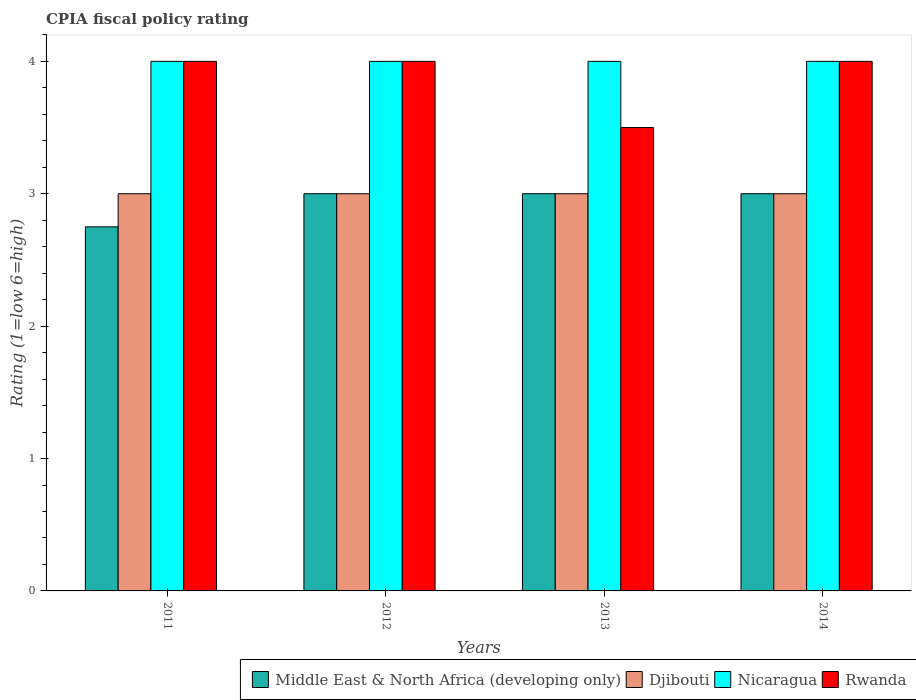How many groups of bars are there?
Provide a succinct answer. 4. Are the number of bars per tick equal to the number of legend labels?
Provide a succinct answer. Yes. Are the number of bars on each tick of the X-axis equal?
Your response must be concise. Yes. How many bars are there on the 1st tick from the right?
Keep it short and to the point. 4. What is the label of the 1st group of bars from the left?
Provide a short and direct response. 2011. What is the CPIA rating in Nicaragua in 2011?
Provide a short and direct response. 4. Across all years, what is the maximum CPIA rating in Nicaragua?
Your answer should be compact. 4. Across all years, what is the minimum CPIA rating in Rwanda?
Make the answer very short. 3.5. In which year was the CPIA rating in Nicaragua maximum?
Make the answer very short. 2011. What is the total CPIA rating in Djibouti in the graph?
Ensure brevity in your answer.  12. In the year 2011, what is the difference between the CPIA rating in Middle East & North Africa (developing only) and CPIA rating in Rwanda?
Your answer should be compact. -1.25. What is the ratio of the CPIA rating in Nicaragua in 2012 to that in 2013?
Make the answer very short. 1. Is the CPIA rating in Rwanda in 2012 less than that in 2014?
Offer a terse response. No. What is the difference between the highest and the second highest CPIA rating in Middle East & North Africa (developing only)?
Make the answer very short. 0. Is the sum of the CPIA rating in Middle East & North Africa (developing only) in 2012 and 2014 greater than the maximum CPIA rating in Rwanda across all years?
Provide a short and direct response. Yes. Is it the case that in every year, the sum of the CPIA rating in Nicaragua and CPIA rating in Djibouti is greater than the sum of CPIA rating in Rwanda and CPIA rating in Middle East & North Africa (developing only)?
Offer a terse response. No. What does the 3rd bar from the left in 2011 represents?
Your answer should be compact. Nicaragua. What does the 2nd bar from the right in 2013 represents?
Ensure brevity in your answer.  Nicaragua. How many bars are there?
Offer a terse response. 16. Are all the bars in the graph horizontal?
Your answer should be compact. No. Where does the legend appear in the graph?
Your response must be concise. Bottom right. How are the legend labels stacked?
Your answer should be very brief. Horizontal. What is the title of the graph?
Your answer should be very brief. CPIA fiscal policy rating. Does "Euro area" appear as one of the legend labels in the graph?
Your answer should be compact. No. What is the label or title of the X-axis?
Provide a short and direct response. Years. What is the Rating (1=low 6=high) in Middle East & North Africa (developing only) in 2011?
Give a very brief answer. 2.75. What is the Rating (1=low 6=high) in Middle East & North Africa (developing only) in 2012?
Offer a very short reply. 3. What is the Rating (1=low 6=high) in Djibouti in 2012?
Keep it short and to the point. 3. What is the Rating (1=low 6=high) in Djibouti in 2013?
Your answer should be very brief. 3. What is the Rating (1=low 6=high) in Nicaragua in 2013?
Your answer should be very brief. 4. What is the Rating (1=low 6=high) of Djibouti in 2014?
Your answer should be very brief. 3. What is the Rating (1=low 6=high) of Rwanda in 2014?
Give a very brief answer. 4. Across all years, what is the maximum Rating (1=low 6=high) in Djibouti?
Your answer should be compact. 3. Across all years, what is the maximum Rating (1=low 6=high) in Rwanda?
Make the answer very short. 4. Across all years, what is the minimum Rating (1=low 6=high) in Middle East & North Africa (developing only)?
Provide a succinct answer. 2.75. Across all years, what is the minimum Rating (1=low 6=high) of Nicaragua?
Provide a succinct answer. 4. Across all years, what is the minimum Rating (1=low 6=high) of Rwanda?
Your response must be concise. 3.5. What is the total Rating (1=low 6=high) of Middle East & North Africa (developing only) in the graph?
Make the answer very short. 11.75. What is the difference between the Rating (1=low 6=high) in Nicaragua in 2011 and that in 2012?
Your response must be concise. 0. What is the difference between the Rating (1=low 6=high) in Rwanda in 2011 and that in 2012?
Offer a terse response. 0. What is the difference between the Rating (1=low 6=high) in Djibouti in 2011 and that in 2013?
Make the answer very short. 0. What is the difference between the Rating (1=low 6=high) in Middle East & North Africa (developing only) in 2011 and that in 2014?
Offer a terse response. -0.25. What is the difference between the Rating (1=low 6=high) of Djibouti in 2011 and that in 2014?
Make the answer very short. 0. What is the difference between the Rating (1=low 6=high) of Nicaragua in 2011 and that in 2014?
Make the answer very short. 0. What is the difference between the Rating (1=low 6=high) of Rwanda in 2011 and that in 2014?
Offer a terse response. 0. What is the difference between the Rating (1=low 6=high) of Middle East & North Africa (developing only) in 2012 and that in 2013?
Your response must be concise. 0. What is the difference between the Rating (1=low 6=high) of Djibouti in 2012 and that in 2013?
Your response must be concise. 0. What is the difference between the Rating (1=low 6=high) of Nicaragua in 2012 and that in 2013?
Give a very brief answer. 0. What is the difference between the Rating (1=low 6=high) of Middle East & North Africa (developing only) in 2012 and that in 2014?
Offer a very short reply. 0. What is the difference between the Rating (1=low 6=high) of Rwanda in 2012 and that in 2014?
Keep it short and to the point. 0. What is the difference between the Rating (1=low 6=high) in Middle East & North Africa (developing only) in 2013 and that in 2014?
Your answer should be compact. 0. What is the difference between the Rating (1=low 6=high) of Middle East & North Africa (developing only) in 2011 and the Rating (1=low 6=high) of Nicaragua in 2012?
Ensure brevity in your answer.  -1.25. What is the difference between the Rating (1=low 6=high) in Middle East & North Africa (developing only) in 2011 and the Rating (1=low 6=high) in Rwanda in 2012?
Provide a succinct answer. -1.25. What is the difference between the Rating (1=low 6=high) of Djibouti in 2011 and the Rating (1=low 6=high) of Rwanda in 2012?
Make the answer very short. -1. What is the difference between the Rating (1=low 6=high) of Nicaragua in 2011 and the Rating (1=low 6=high) of Rwanda in 2012?
Provide a short and direct response. 0. What is the difference between the Rating (1=low 6=high) of Middle East & North Africa (developing only) in 2011 and the Rating (1=low 6=high) of Djibouti in 2013?
Give a very brief answer. -0.25. What is the difference between the Rating (1=low 6=high) in Middle East & North Africa (developing only) in 2011 and the Rating (1=low 6=high) in Nicaragua in 2013?
Provide a short and direct response. -1.25. What is the difference between the Rating (1=low 6=high) in Middle East & North Africa (developing only) in 2011 and the Rating (1=low 6=high) in Rwanda in 2013?
Ensure brevity in your answer.  -0.75. What is the difference between the Rating (1=low 6=high) in Djibouti in 2011 and the Rating (1=low 6=high) in Nicaragua in 2013?
Ensure brevity in your answer.  -1. What is the difference between the Rating (1=low 6=high) in Djibouti in 2011 and the Rating (1=low 6=high) in Rwanda in 2013?
Provide a short and direct response. -0.5. What is the difference between the Rating (1=low 6=high) of Middle East & North Africa (developing only) in 2011 and the Rating (1=low 6=high) of Nicaragua in 2014?
Provide a short and direct response. -1.25. What is the difference between the Rating (1=low 6=high) of Middle East & North Africa (developing only) in 2011 and the Rating (1=low 6=high) of Rwanda in 2014?
Provide a short and direct response. -1.25. What is the difference between the Rating (1=low 6=high) of Middle East & North Africa (developing only) in 2012 and the Rating (1=low 6=high) of Nicaragua in 2013?
Offer a terse response. -1. What is the difference between the Rating (1=low 6=high) in Djibouti in 2012 and the Rating (1=low 6=high) in Nicaragua in 2013?
Provide a short and direct response. -1. What is the difference between the Rating (1=low 6=high) in Djibouti in 2012 and the Rating (1=low 6=high) in Rwanda in 2013?
Make the answer very short. -0.5. What is the difference between the Rating (1=low 6=high) of Nicaragua in 2012 and the Rating (1=low 6=high) of Rwanda in 2013?
Offer a very short reply. 0.5. What is the difference between the Rating (1=low 6=high) in Middle East & North Africa (developing only) in 2012 and the Rating (1=low 6=high) in Nicaragua in 2014?
Offer a terse response. -1. What is the difference between the Rating (1=low 6=high) of Middle East & North Africa (developing only) in 2012 and the Rating (1=low 6=high) of Rwanda in 2014?
Make the answer very short. -1. What is the difference between the Rating (1=low 6=high) in Middle East & North Africa (developing only) in 2013 and the Rating (1=low 6=high) in Djibouti in 2014?
Ensure brevity in your answer.  0. What is the difference between the Rating (1=low 6=high) of Middle East & North Africa (developing only) in 2013 and the Rating (1=low 6=high) of Rwanda in 2014?
Provide a short and direct response. -1. What is the difference between the Rating (1=low 6=high) in Djibouti in 2013 and the Rating (1=low 6=high) in Nicaragua in 2014?
Offer a very short reply. -1. What is the difference between the Rating (1=low 6=high) in Nicaragua in 2013 and the Rating (1=low 6=high) in Rwanda in 2014?
Give a very brief answer. 0. What is the average Rating (1=low 6=high) of Middle East & North Africa (developing only) per year?
Ensure brevity in your answer.  2.94. What is the average Rating (1=low 6=high) of Rwanda per year?
Your answer should be compact. 3.88. In the year 2011, what is the difference between the Rating (1=low 6=high) of Middle East & North Africa (developing only) and Rating (1=low 6=high) of Djibouti?
Ensure brevity in your answer.  -0.25. In the year 2011, what is the difference between the Rating (1=low 6=high) of Middle East & North Africa (developing only) and Rating (1=low 6=high) of Nicaragua?
Your response must be concise. -1.25. In the year 2011, what is the difference between the Rating (1=low 6=high) of Middle East & North Africa (developing only) and Rating (1=low 6=high) of Rwanda?
Provide a short and direct response. -1.25. In the year 2011, what is the difference between the Rating (1=low 6=high) of Djibouti and Rating (1=low 6=high) of Nicaragua?
Give a very brief answer. -1. In the year 2011, what is the difference between the Rating (1=low 6=high) in Djibouti and Rating (1=low 6=high) in Rwanda?
Make the answer very short. -1. In the year 2011, what is the difference between the Rating (1=low 6=high) in Nicaragua and Rating (1=low 6=high) in Rwanda?
Your answer should be compact. 0. In the year 2012, what is the difference between the Rating (1=low 6=high) in Middle East & North Africa (developing only) and Rating (1=low 6=high) in Djibouti?
Your answer should be compact. 0. In the year 2012, what is the difference between the Rating (1=low 6=high) of Middle East & North Africa (developing only) and Rating (1=low 6=high) of Nicaragua?
Keep it short and to the point. -1. In the year 2012, what is the difference between the Rating (1=low 6=high) in Middle East & North Africa (developing only) and Rating (1=low 6=high) in Rwanda?
Your response must be concise. -1. In the year 2012, what is the difference between the Rating (1=low 6=high) in Djibouti and Rating (1=low 6=high) in Nicaragua?
Provide a short and direct response. -1. In the year 2013, what is the difference between the Rating (1=low 6=high) of Middle East & North Africa (developing only) and Rating (1=low 6=high) of Nicaragua?
Give a very brief answer. -1. In the year 2013, what is the difference between the Rating (1=low 6=high) in Middle East & North Africa (developing only) and Rating (1=low 6=high) in Rwanda?
Your response must be concise. -0.5. In the year 2013, what is the difference between the Rating (1=low 6=high) in Djibouti and Rating (1=low 6=high) in Rwanda?
Your answer should be compact. -0.5. In the year 2013, what is the difference between the Rating (1=low 6=high) of Nicaragua and Rating (1=low 6=high) of Rwanda?
Ensure brevity in your answer.  0.5. In the year 2014, what is the difference between the Rating (1=low 6=high) in Middle East & North Africa (developing only) and Rating (1=low 6=high) in Nicaragua?
Ensure brevity in your answer.  -1. In the year 2014, what is the difference between the Rating (1=low 6=high) of Middle East & North Africa (developing only) and Rating (1=low 6=high) of Rwanda?
Make the answer very short. -1. In the year 2014, what is the difference between the Rating (1=low 6=high) of Djibouti and Rating (1=low 6=high) of Rwanda?
Give a very brief answer. -1. In the year 2014, what is the difference between the Rating (1=low 6=high) of Nicaragua and Rating (1=low 6=high) of Rwanda?
Offer a very short reply. 0. What is the ratio of the Rating (1=low 6=high) of Middle East & North Africa (developing only) in 2011 to that in 2012?
Offer a very short reply. 0.92. What is the ratio of the Rating (1=low 6=high) of Nicaragua in 2011 to that in 2012?
Offer a terse response. 1. What is the ratio of the Rating (1=low 6=high) in Middle East & North Africa (developing only) in 2011 to that in 2013?
Your answer should be very brief. 0.92. What is the ratio of the Rating (1=low 6=high) of Rwanda in 2011 to that in 2013?
Ensure brevity in your answer.  1.14. What is the ratio of the Rating (1=low 6=high) of Djibouti in 2011 to that in 2014?
Make the answer very short. 1. What is the ratio of the Rating (1=low 6=high) in Nicaragua in 2011 to that in 2014?
Keep it short and to the point. 1. What is the ratio of the Rating (1=low 6=high) in Rwanda in 2011 to that in 2014?
Provide a short and direct response. 1. What is the ratio of the Rating (1=low 6=high) in Djibouti in 2012 to that in 2013?
Your answer should be compact. 1. What is the ratio of the Rating (1=low 6=high) of Nicaragua in 2012 to that in 2013?
Provide a succinct answer. 1. What is the ratio of the Rating (1=low 6=high) of Rwanda in 2012 to that in 2013?
Provide a succinct answer. 1.14. What is the ratio of the Rating (1=low 6=high) in Middle East & North Africa (developing only) in 2012 to that in 2014?
Provide a succinct answer. 1. What is the ratio of the Rating (1=low 6=high) of Nicaragua in 2012 to that in 2014?
Your response must be concise. 1. What is the ratio of the Rating (1=low 6=high) in Rwanda in 2012 to that in 2014?
Your answer should be very brief. 1. What is the ratio of the Rating (1=low 6=high) in Middle East & North Africa (developing only) in 2013 to that in 2014?
Your answer should be compact. 1. What is the ratio of the Rating (1=low 6=high) in Djibouti in 2013 to that in 2014?
Your answer should be compact. 1. What is the difference between the highest and the lowest Rating (1=low 6=high) in Middle East & North Africa (developing only)?
Your answer should be very brief. 0.25. What is the difference between the highest and the lowest Rating (1=low 6=high) in Nicaragua?
Keep it short and to the point. 0. 